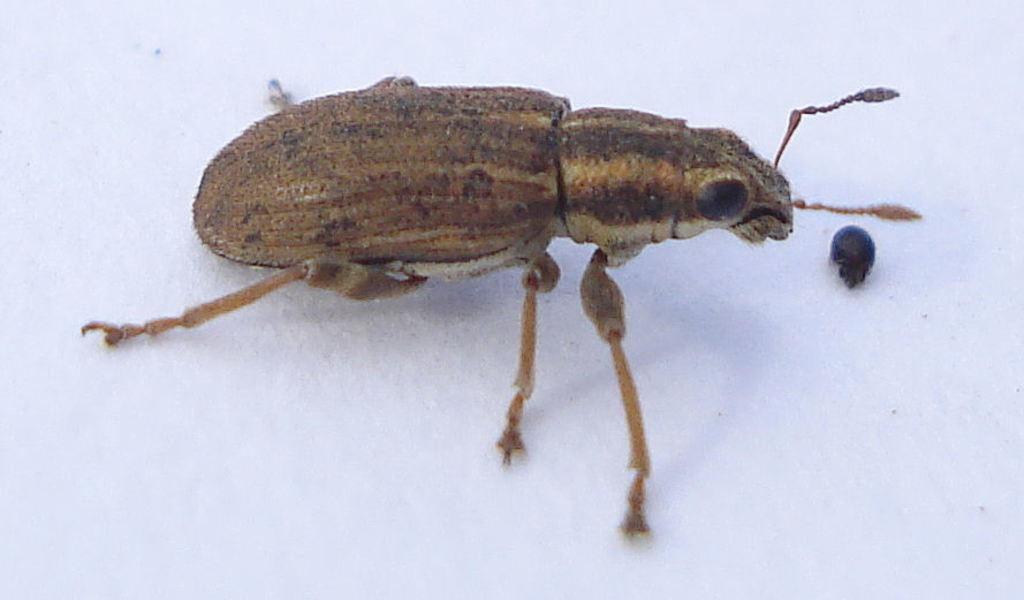What is the focus of the image? The image is zoomed in on an insect. Can you describe the insect in the image? The insect is in the center of the image. What color is the object the insect is on? The object the insect is on is white in color. What type of worm can be seen in the stew in the image? There is no stew or worm present in the image; it features a zoomed-in view of an insect on a white object. 